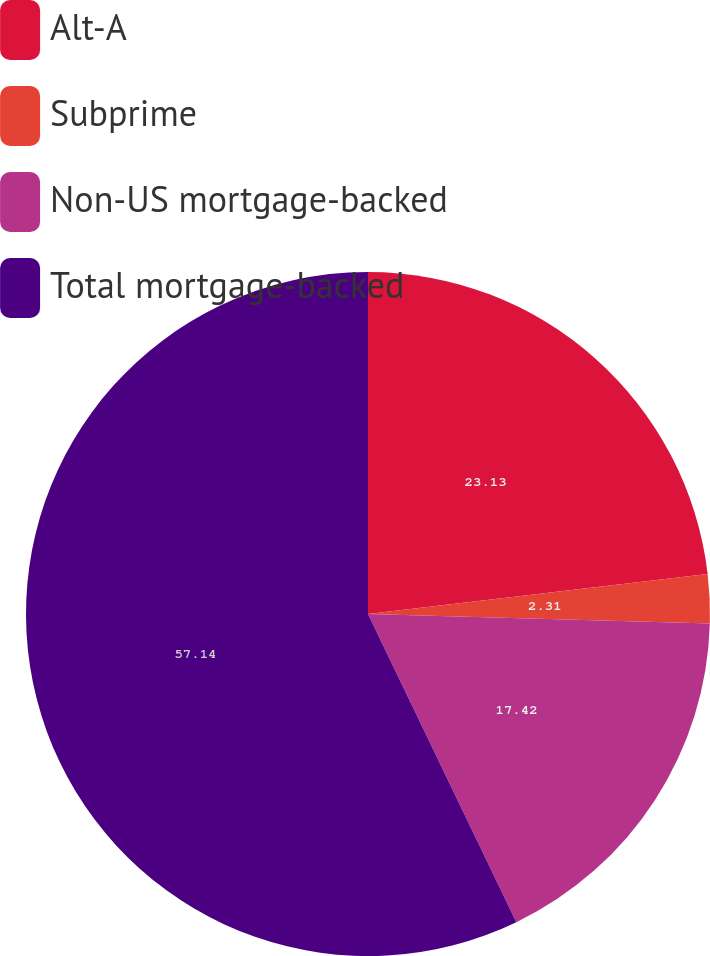Convert chart. <chart><loc_0><loc_0><loc_500><loc_500><pie_chart><fcel>Alt-A<fcel>Subprime<fcel>Non-US mortgage-backed<fcel>Total mortgage-backed<nl><fcel>23.13%<fcel>2.31%<fcel>17.42%<fcel>57.14%<nl></chart> 